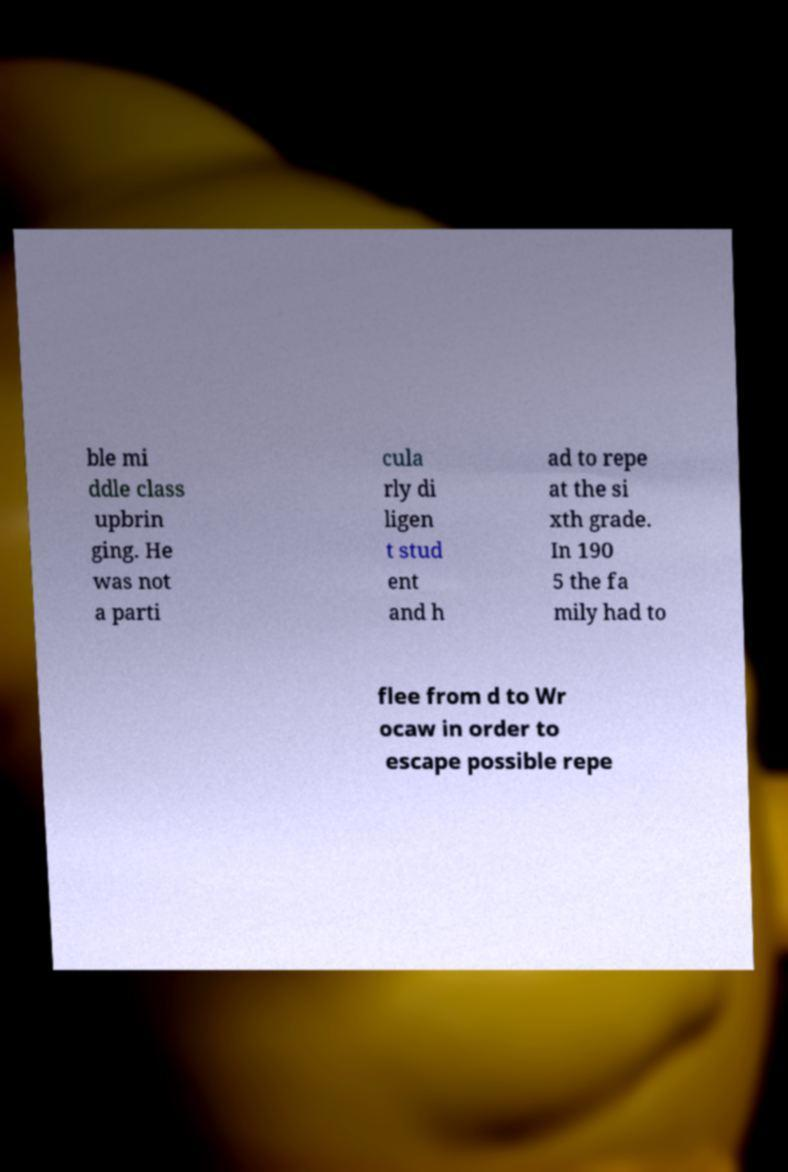I need the written content from this picture converted into text. Can you do that? ble mi ddle class upbrin ging. He was not a parti cula rly di ligen t stud ent and h ad to repe at the si xth grade. In 190 5 the fa mily had to flee from d to Wr ocaw in order to escape possible repe 